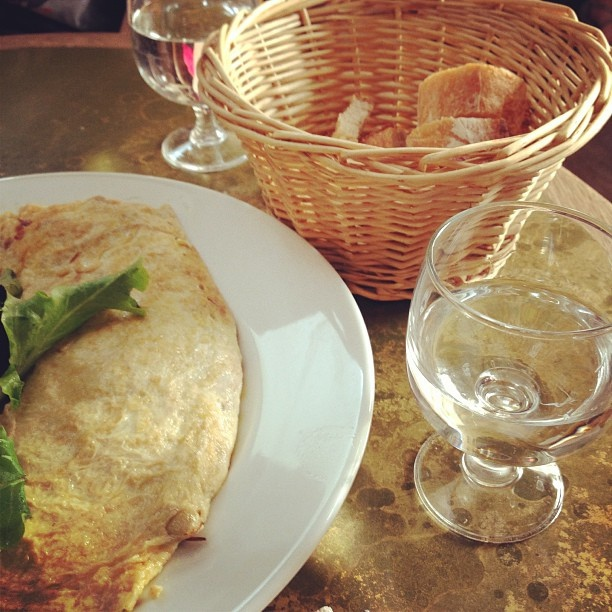Describe the objects in this image and their specific colors. I can see dining table in black, tan, gray, and brown tones, sandwich in black, tan, olive, and darkgreen tones, wine glass in black, tan, gray, and ivory tones, and wine glass in black, gray, tan, and brown tones in this image. 